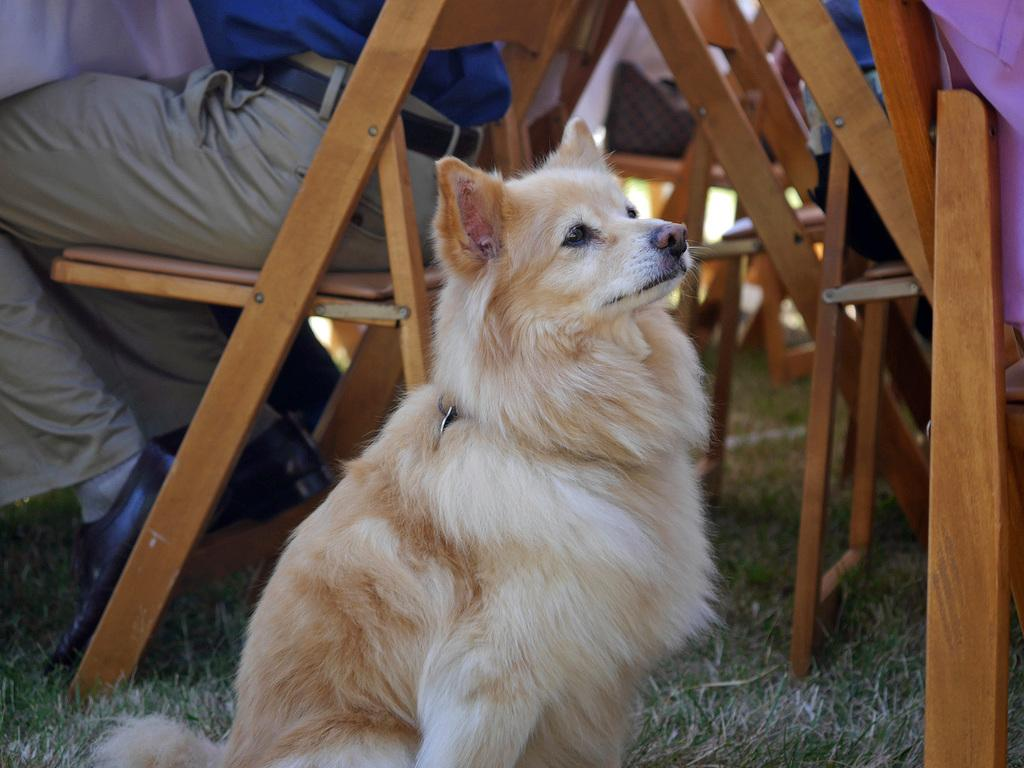What animal can be seen in the image? There is a dog in the image. Where is the dog located? The dog is sitting on the grass. What can be seen in the background of the image? There are chairs in the background of the image. What are the people in the background doing? People are sitting on the chairs in the background. What type of thrill can be seen on the dog's face in the image? There is no indication of a thrill or any specific emotion on the dog's face in the image. 